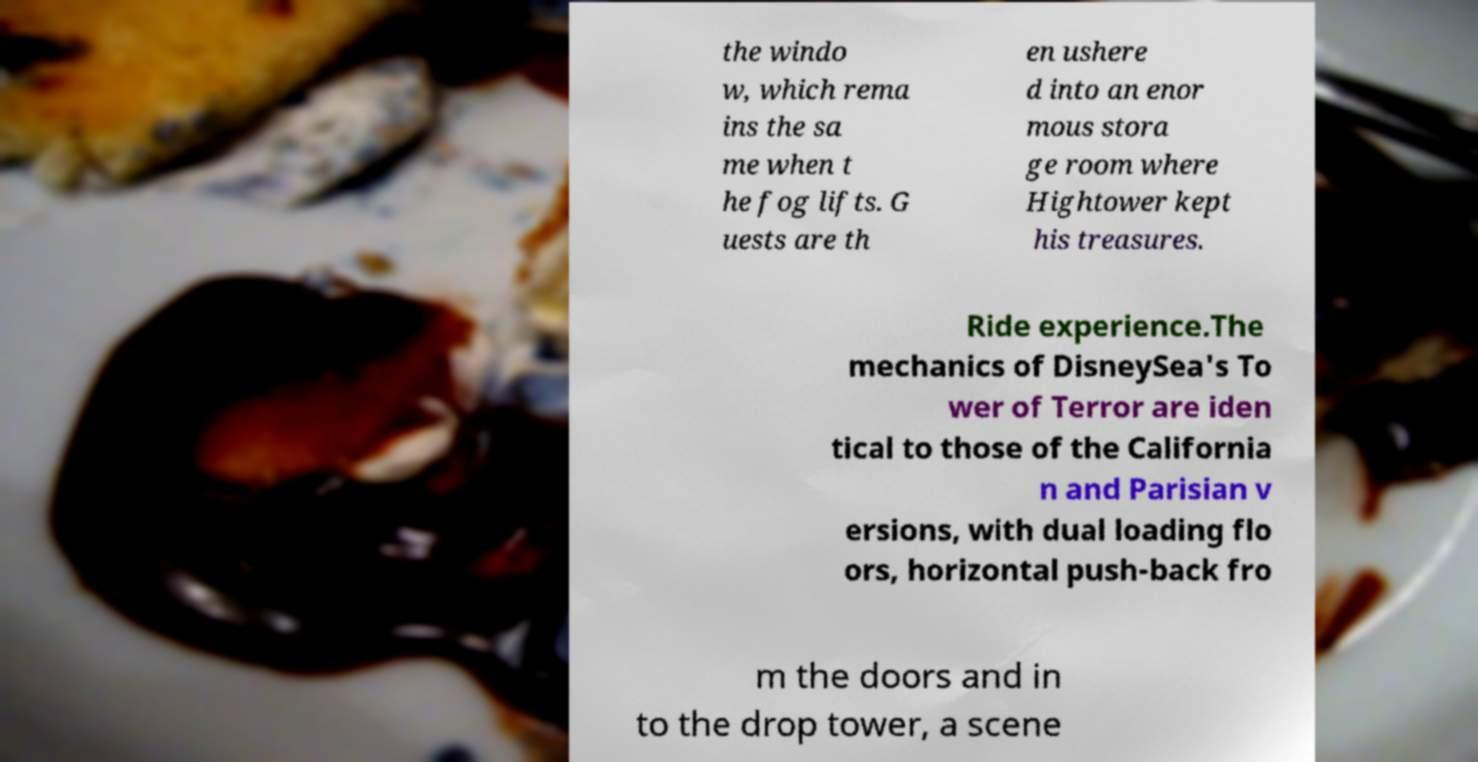Could you assist in decoding the text presented in this image and type it out clearly? the windo w, which rema ins the sa me when t he fog lifts. G uests are th en ushere d into an enor mous stora ge room where Hightower kept his treasures. Ride experience.The mechanics of DisneySea's To wer of Terror are iden tical to those of the California n and Parisian v ersions, with dual loading flo ors, horizontal push-back fro m the doors and in to the drop tower, a scene 